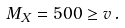<formula> <loc_0><loc_0><loc_500><loc_500>M _ { X } = 5 0 0 \geq v \, .</formula> 